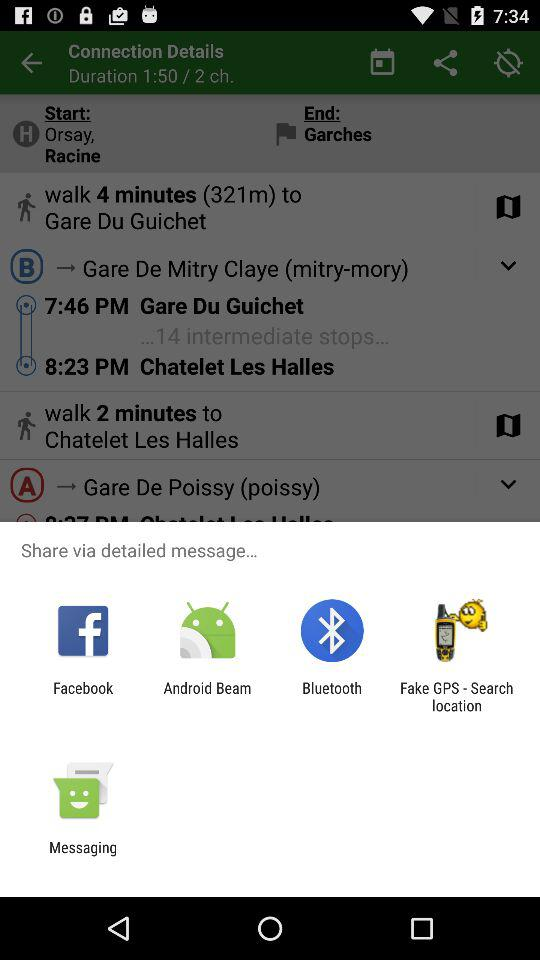How many intermediate stops are there on this journey?
Answer the question using a single word or phrase. 14 